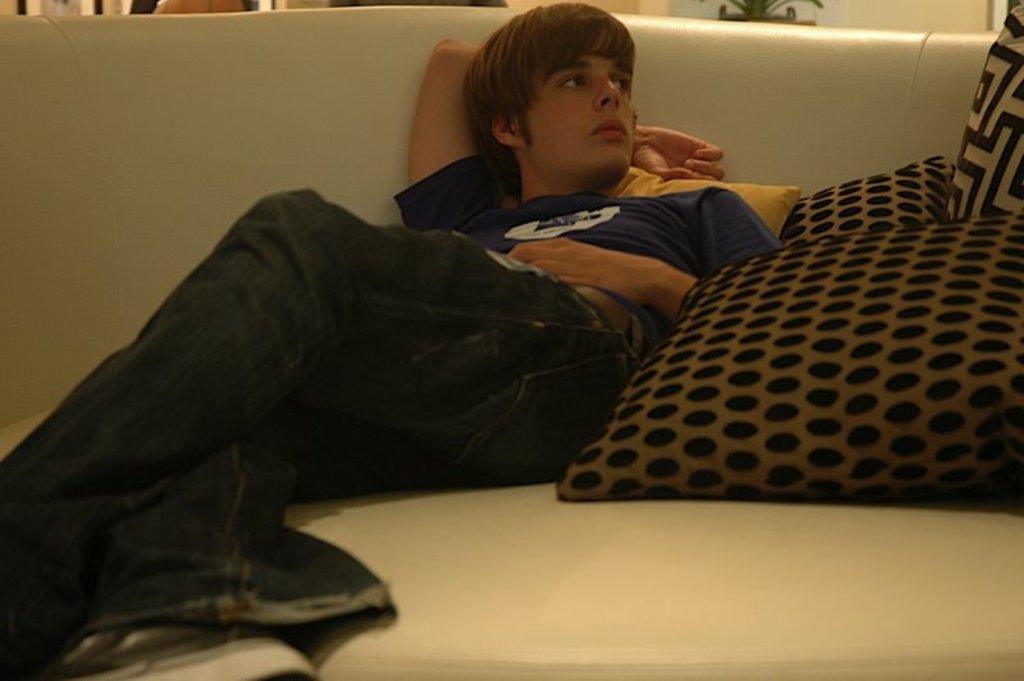Who is present in the image? There is a man in the image. What is the man doing in the image? The man is laying on a couch. What can be seen on the couch with the man? There are pillows in the image. What type of letter is the man holding in the image? There is no letter present in the image; the man is laying on a couch with pillows. 